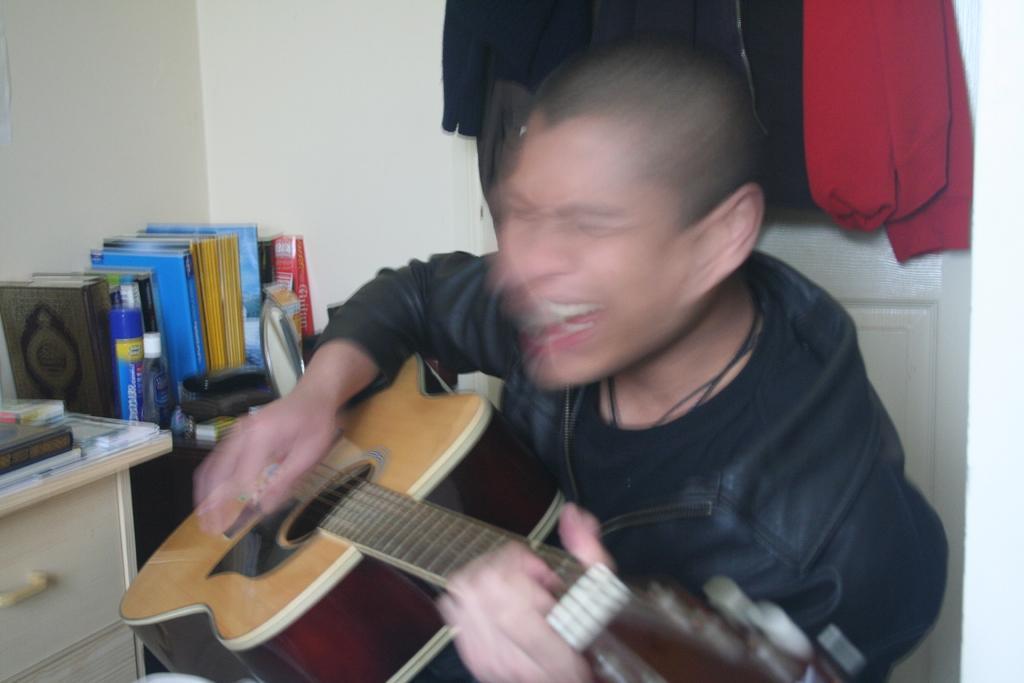Describe this image in one or two sentences. This picture contains a person playing a guitar. At the left side there are few books beside there is a table. At the right top there are clothes. 